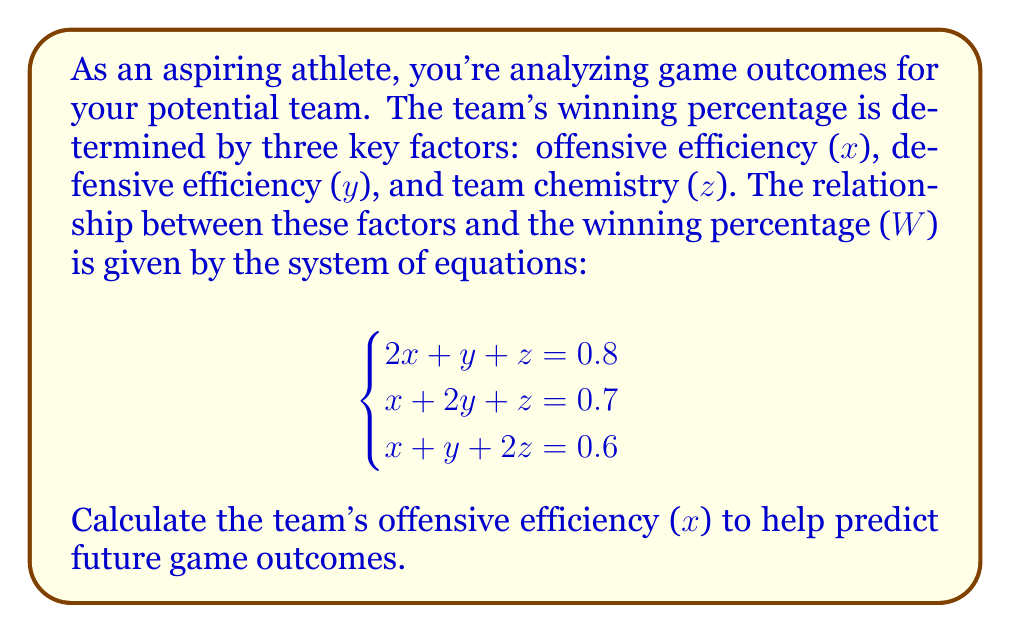Help me with this question. To solve this system of equations, we'll use the elimination method:

1) Subtract equation 2 from equation 1:
   $$(2x + y + z) - (x + 2y + z) = 0.8 - 0.7$$
   $$x - y = 0.1 \quad \text{(Equation 4)}$$

2) Subtract equation 3 from equation 1:
   $$(2x + y + z) - (x + y + 2z) = 0.8 - 0.6$$
   $$x - z = 0.2 \quad \text{(Equation 5)}$$

3) From Equation 4: $x = y + 0.1$
   From Equation 5: $x = z + 0.2$

4) Substitute these into equation 1:
   $$2(y + 0.1) + y + (z + 0.2) = 0.8$$
   $$2y + 0.2 + y + z + 0.2 = 0.8$$
   $$3y + z = 0.4$$

5) Substitute $z = x - 0.2$ (from Equation 5) into this new equation:
   $$3y + (x - 0.2) = 0.4$$
   $$3y + x = 0.6$$

6) Now we have:
   $$x = y + 0.1$$
   $$3y + x = 0.6$$

7) Substitute the first equation into the second:
   $$3y + (y + 0.1) = 0.6$$
   $$4y = 0.5$$
   $$y = 0.125$$

8) Finally, calculate x:
   $$x = y + 0.1 = 0.125 + 0.1 = 0.225$$

Therefore, the offensive efficiency (x) is 0.225 or 22.5%.
Answer: 0.225 